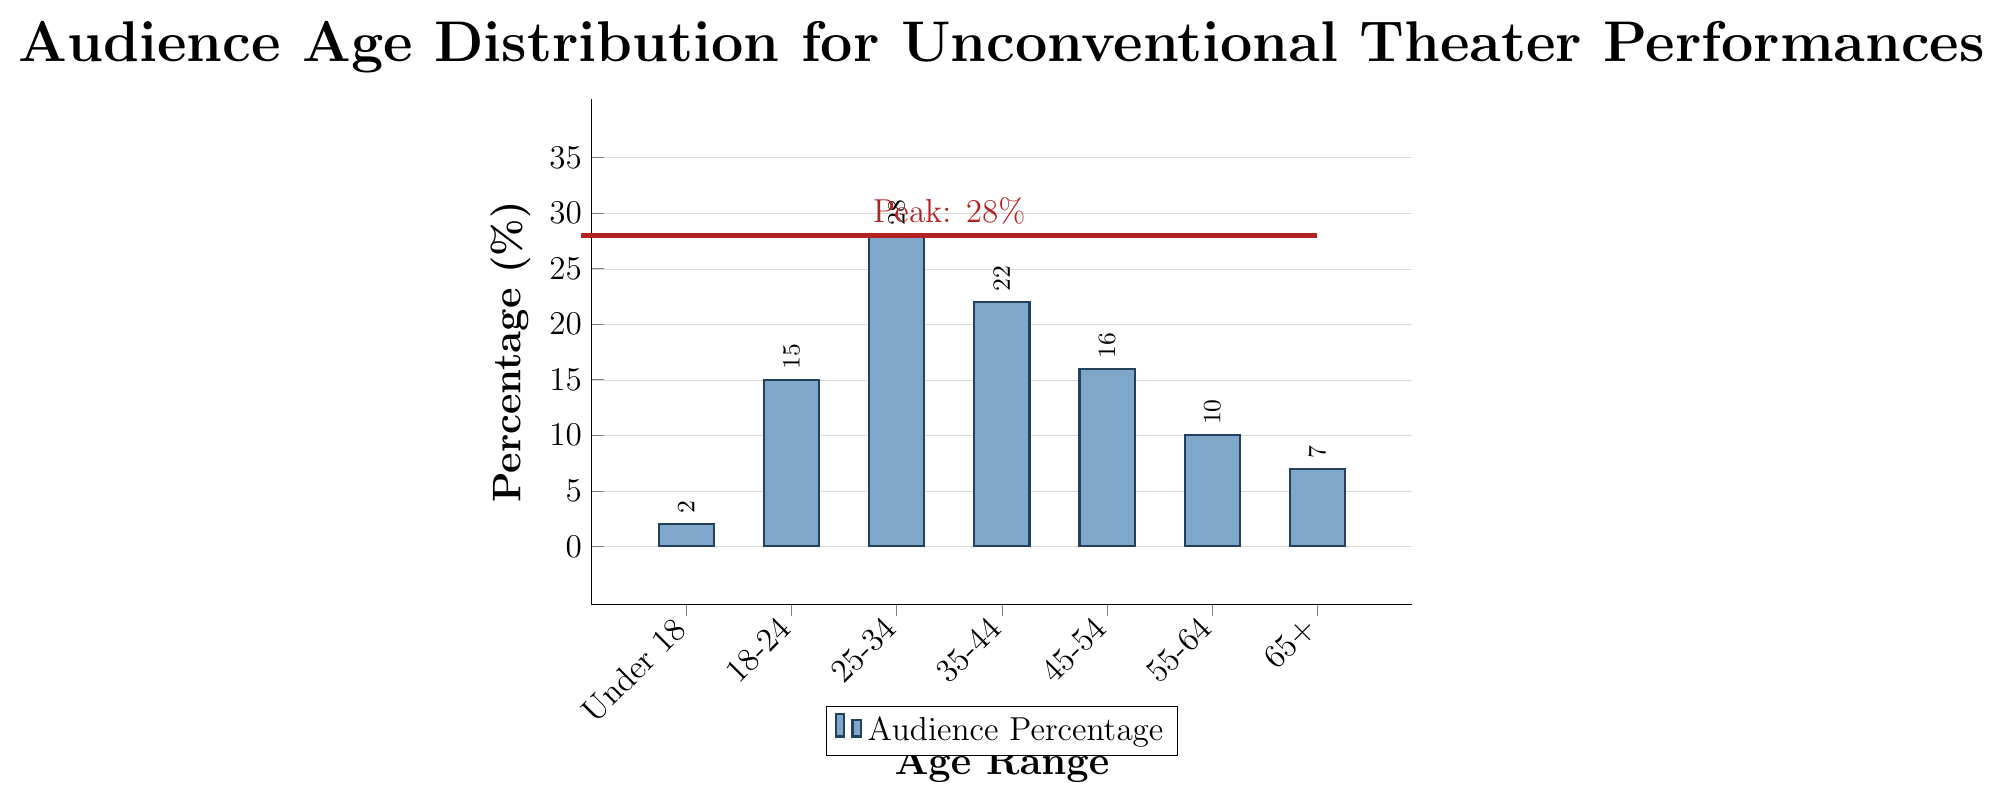Which age range has the highest percentage of audience members? The bar representing the age range 25-34 is the tallest, reaching up to 28%. This indicates that the 25-34 age range has the highest percentage of audience members.
Answer: 25-34 What is the total percentage of audience members younger than 35? To find the total percentage of audience members younger than 35, add the percentages for the age ranges Under 18, 18-24, and 25-34. Thus, 2% + 15% + 28% = 45%.
Answer: 45% Are there more audience members in the age range 35-44 or 55-64? Compare the heights of the bars for the age ranges 35-44 and 55-64. The bar for 35-44 is taller (22%) than the bar for 55-64 (10%).
Answer: 35-44 Which age range has the least number of audience members? The bar for the age range Under 18 is the shortest, indicating the lowest percentage of audience members at 2%.
Answer: Under 18 What is the difference in audience percentage between age ranges 25-34 and 65+? Subtract the percentage for age range 65+ from the percentage for age range 25-34: 28% - 7% = 21%.
Answer: 21% How does the audience percentage for the age range 18-24 compare against those aged 45 and over? Add the percentages for the age ranges 45-54, 55-64, and 65+, then compare it with the percentage for 18-24. So, 16% + 10% + 7% = 33% for 45 and over, and the percentage for 18-24 is 15%.
Answer: 45 and over is greater Calculate the average percentage of audience members for all age ranges. Sum all the percentages and then divide by the number of age ranges: (2% + 15% + 28% + 22% + 16% + 10% + 7%) / 7 = 100% / 7 ≈ 14.29%.
Answer: Approximately 14.29% How many age ranges have a percentage of audience greater than 20%? Identify the age ranges where the bar heights exceed 20%. The relevant age ranges are 25-34 (28%) and 35-44 (22%).
Answer: 2 What is the combined percentage of audience members within the age range 18-54? Sum the percentages for the age ranges 18-24, 25-34, 35-44, and 45-54: 15% + 28% + 22% + 16% = 81%.
Answer: 81% 